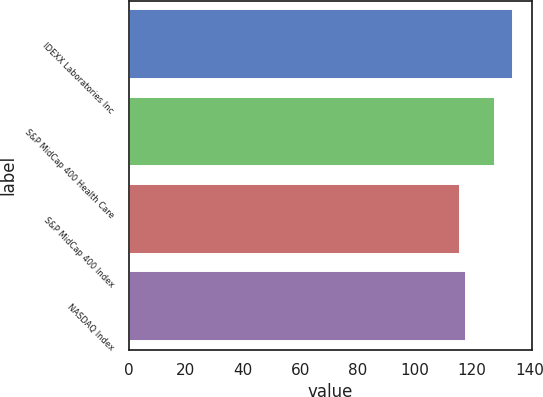<chart> <loc_0><loc_0><loc_500><loc_500><bar_chart><fcel>IDEXX Laboratories Inc<fcel>S&P MidCap 400 Health Care<fcel>S&P MidCap 400 Index<fcel>NASDAQ Index<nl><fcel>134.07<fcel>128.1<fcel>115.84<fcel>117.66<nl></chart> 